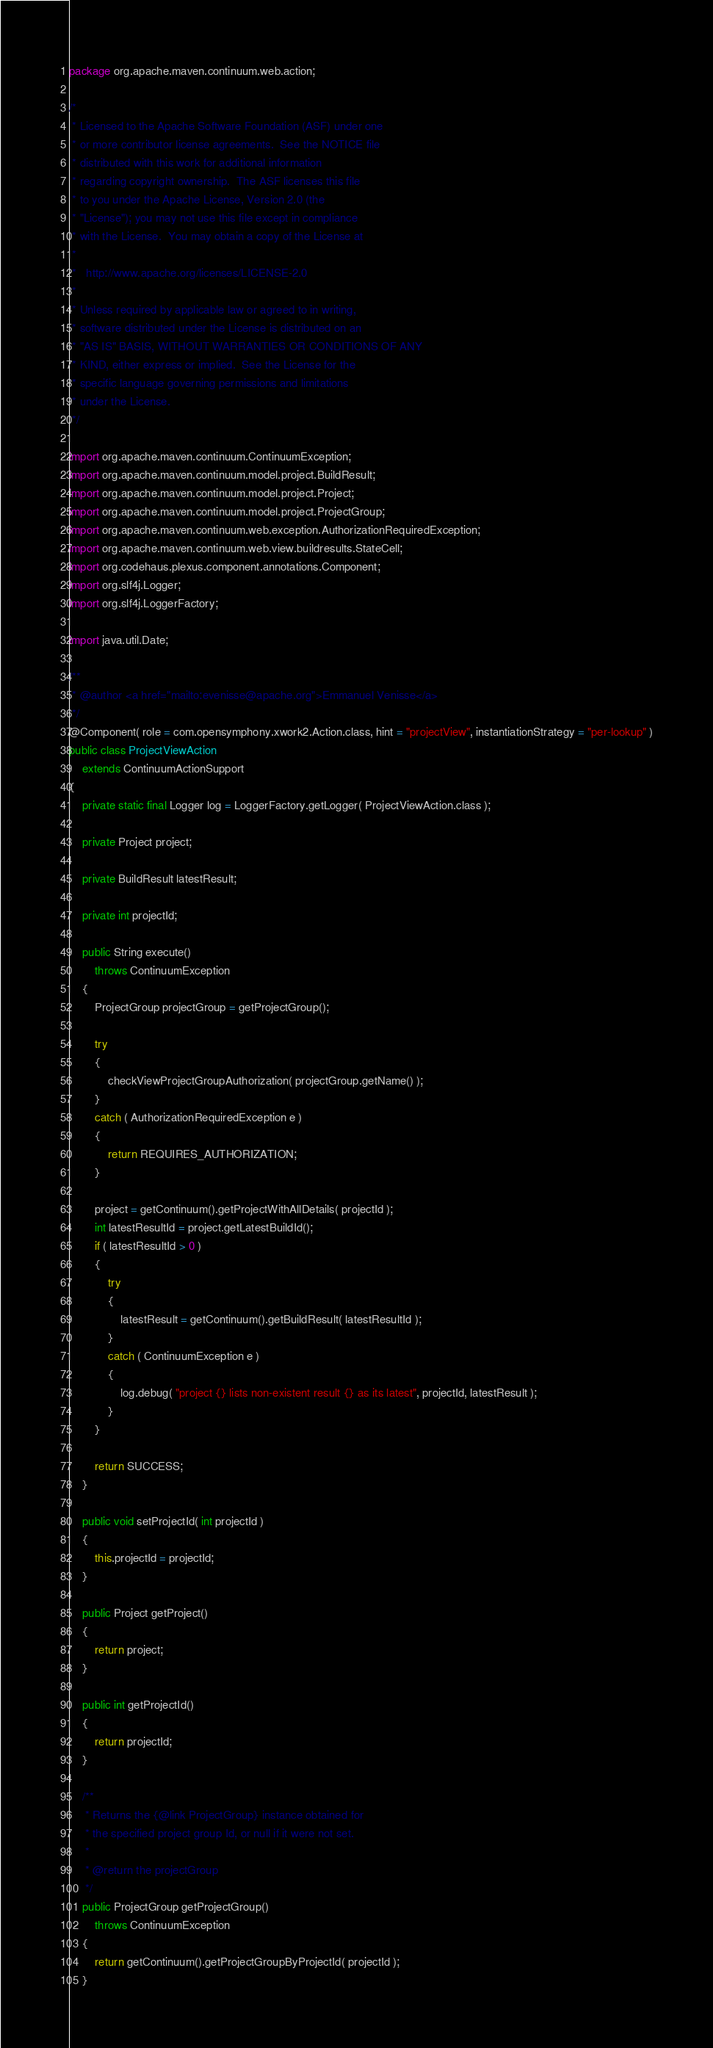Convert code to text. <code><loc_0><loc_0><loc_500><loc_500><_Java_>package org.apache.maven.continuum.web.action;

/*
 * Licensed to the Apache Software Foundation (ASF) under one
 * or more contributor license agreements.  See the NOTICE file
 * distributed with this work for additional information
 * regarding copyright ownership.  The ASF licenses this file
 * to you under the Apache License, Version 2.0 (the
 * "License"); you may not use this file except in compliance
 * with the License.  You may obtain a copy of the License at
 *
 *   http://www.apache.org/licenses/LICENSE-2.0
 *
 * Unless required by applicable law or agreed to in writing,
 * software distributed under the License is distributed on an
 * "AS IS" BASIS, WITHOUT WARRANTIES OR CONDITIONS OF ANY
 * KIND, either express or implied.  See the License for the
 * specific language governing permissions and limitations
 * under the License.
 */

import org.apache.maven.continuum.ContinuumException;
import org.apache.maven.continuum.model.project.BuildResult;
import org.apache.maven.continuum.model.project.Project;
import org.apache.maven.continuum.model.project.ProjectGroup;
import org.apache.maven.continuum.web.exception.AuthorizationRequiredException;
import org.apache.maven.continuum.web.view.buildresults.StateCell;
import org.codehaus.plexus.component.annotations.Component;
import org.slf4j.Logger;
import org.slf4j.LoggerFactory;

import java.util.Date;

/**
 * @author <a href="mailto:evenisse@apache.org">Emmanuel Venisse</a>
 */
@Component( role = com.opensymphony.xwork2.Action.class, hint = "projectView", instantiationStrategy = "per-lookup" )
public class ProjectViewAction
    extends ContinuumActionSupport
{
    private static final Logger log = LoggerFactory.getLogger( ProjectViewAction.class );

    private Project project;

    private BuildResult latestResult;

    private int projectId;

    public String execute()
        throws ContinuumException
    {
        ProjectGroup projectGroup = getProjectGroup();

        try
        {
            checkViewProjectGroupAuthorization( projectGroup.getName() );
        }
        catch ( AuthorizationRequiredException e )
        {
            return REQUIRES_AUTHORIZATION;
        }

        project = getContinuum().getProjectWithAllDetails( projectId );
        int latestResultId = project.getLatestBuildId();
        if ( latestResultId > 0 )
        {
            try
            {
                latestResult = getContinuum().getBuildResult( latestResultId );
            }
            catch ( ContinuumException e )
            {
                log.debug( "project {} lists non-existent result {} as its latest", projectId, latestResult );
            }
        }

        return SUCCESS;
    }

    public void setProjectId( int projectId )
    {
        this.projectId = projectId;
    }

    public Project getProject()
    {
        return project;
    }

    public int getProjectId()
    {
        return projectId;
    }

    /**
     * Returns the {@link ProjectGroup} instance obtained for
     * the specified project group Id, or null if it were not set.
     *
     * @return the projectGroup
     */
    public ProjectGroup getProjectGroup()
        throws ContinuumException
    {
        return getContinuum().getProjectGroupByProjectId( projectId );
    }
</code> 